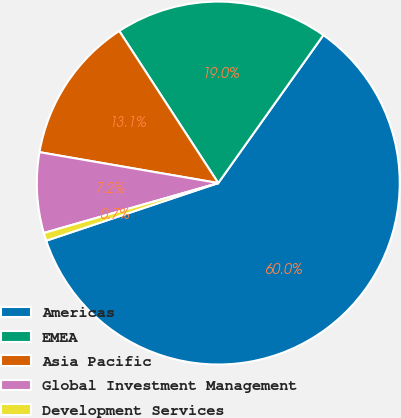<chart> <loc_0><loc_0><loc_500><loc_500><pie_chart><fcel>Americas<fcel>EMEA<fcel>Asia Pacific<fcel>Global Investment Management<fcel>Development Services<nl><fcel>60.02%<fcel>19.02%<fcel>13.09%<fcel>7.16%<fcel>0.71%<nl></chart> 